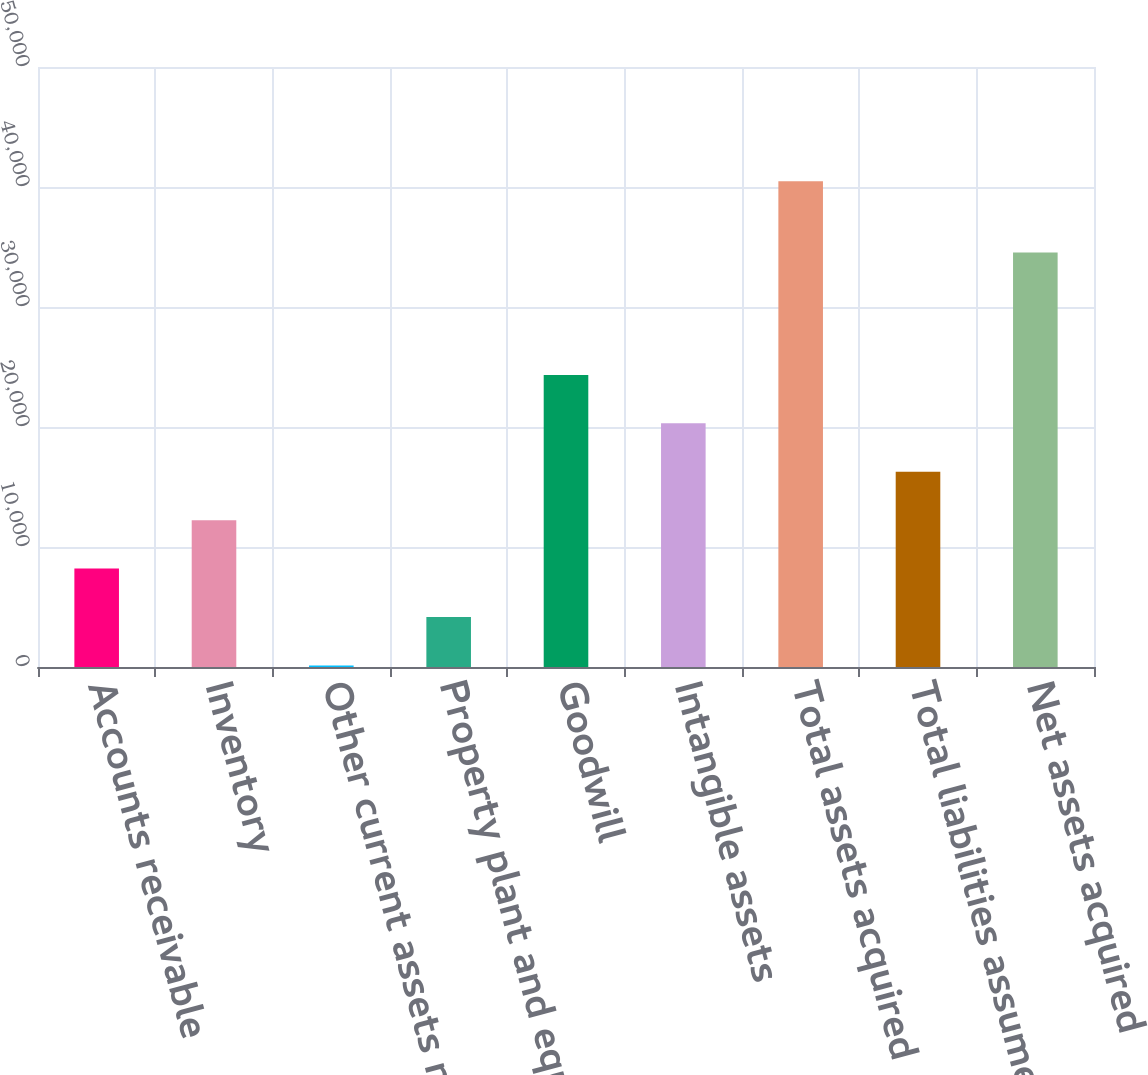Convert chart. <chart><loc_0><loc_0><loc_500><loc_500><bar_chart><fcel>Accounts receivable<fcel>Inventory<fcel>Other current assets net of<fcel>Property plant and equipment<fcel>Goodwill<fcel>Intangible assets<fcel>Total assets acquired<fcel>Total liabilities assumed<fcel>Net assets acquired<nl><fcel>8200<fcel>12234.5<fcel>131<fcel>4165.5<fcel>24338<fcel>20303.5<fcel>40476<fcel>16269<fcel>34537<nl></chart> 